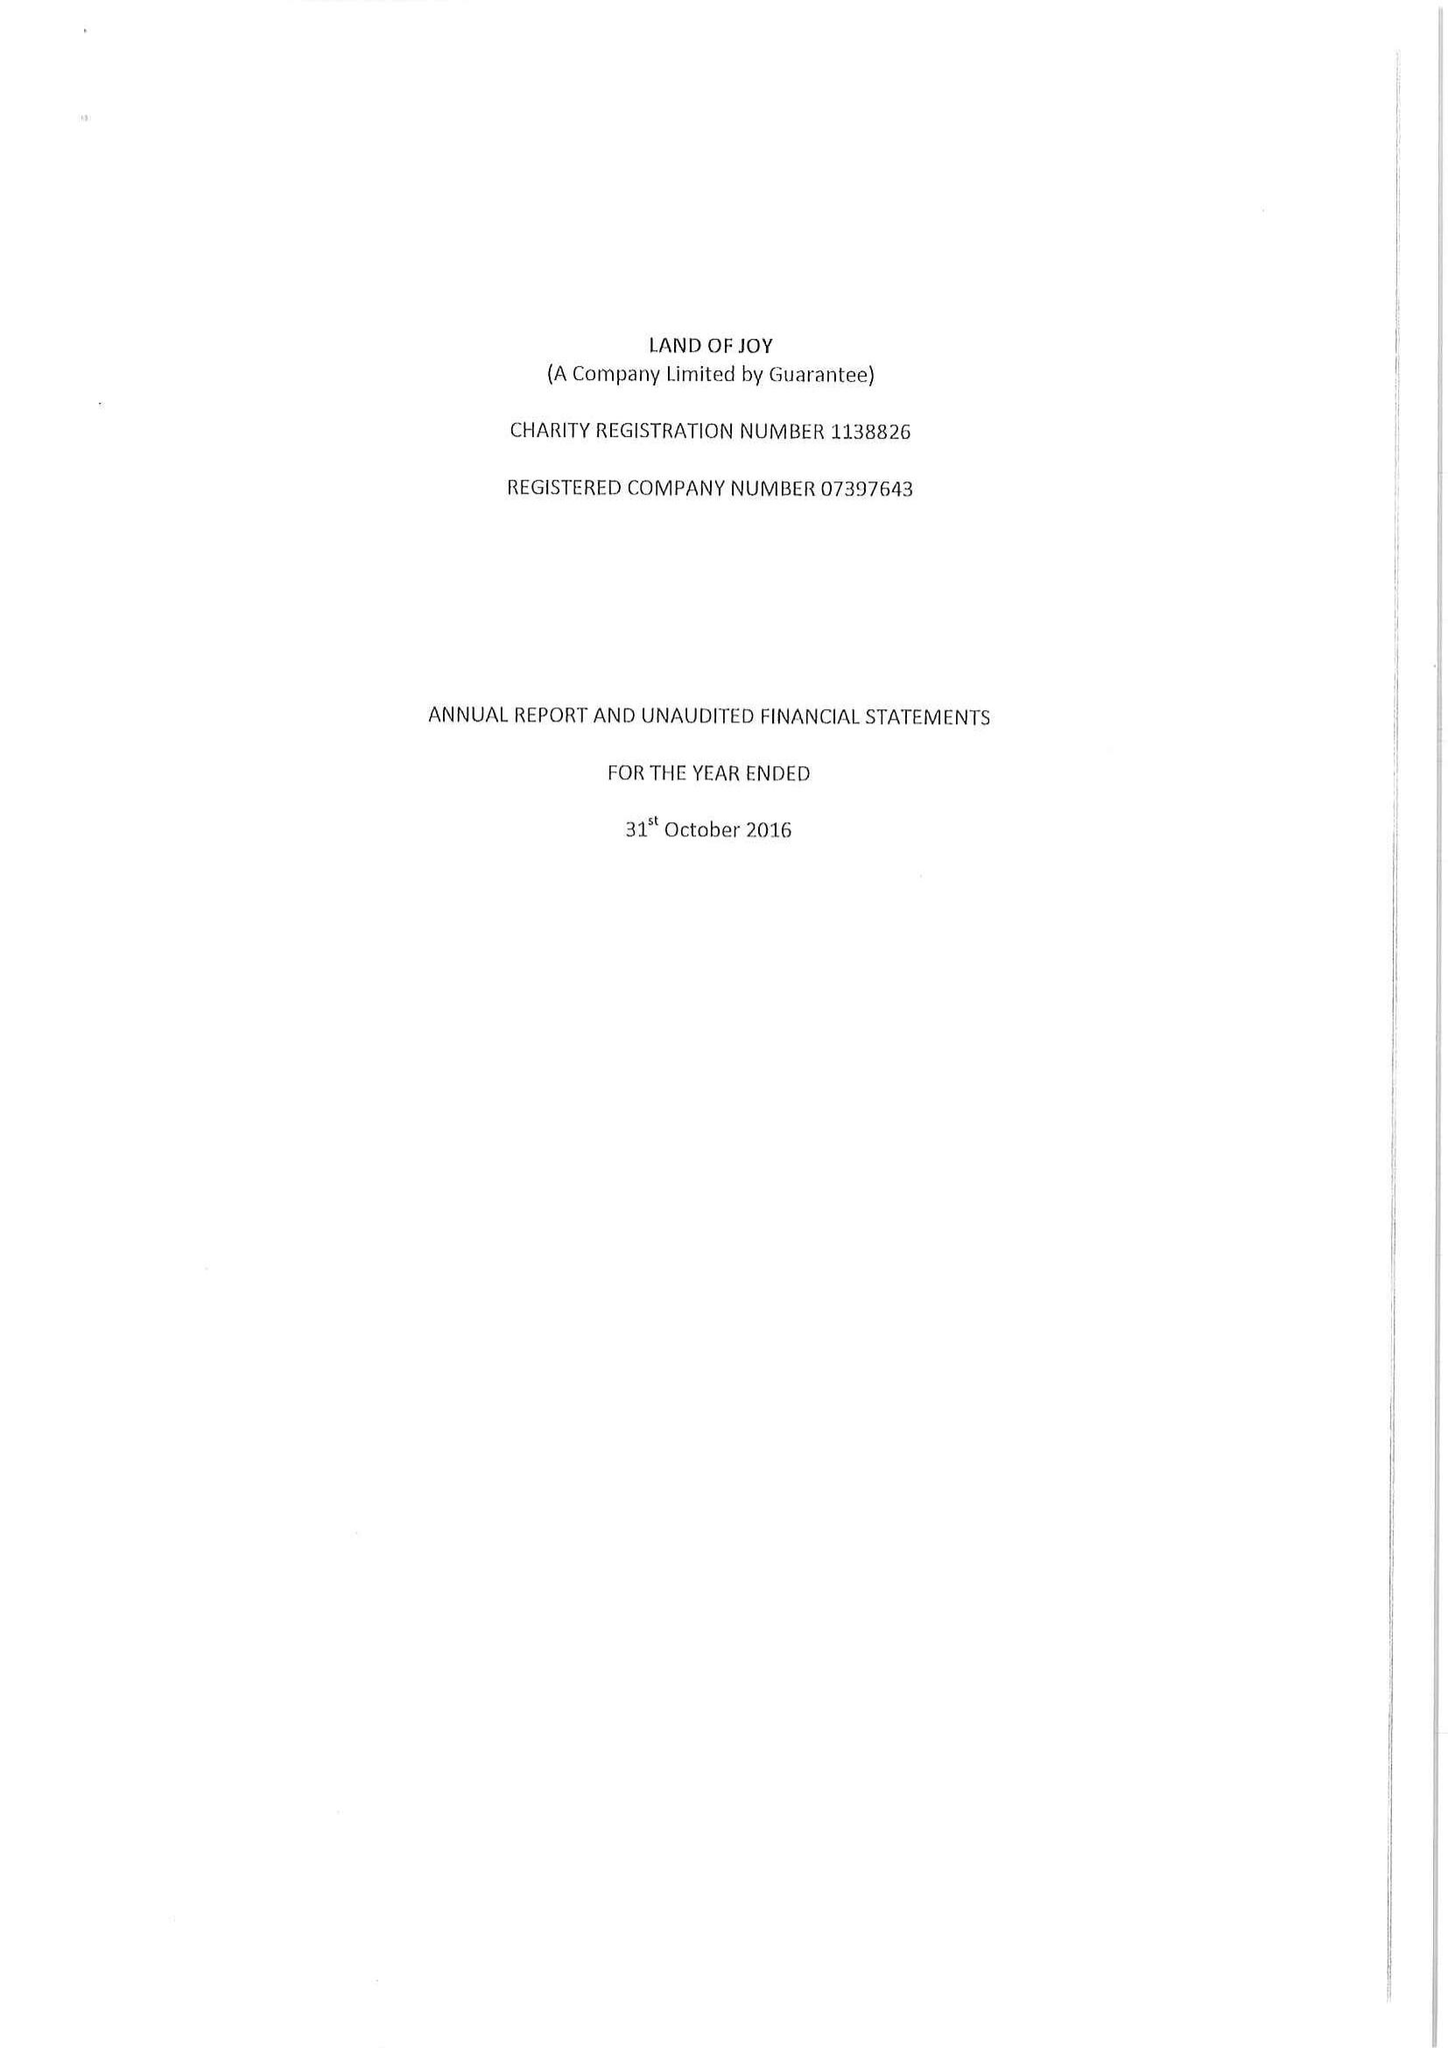What is the value for the address__street_line?
Answer the question using a single word or phrase. GREENHAUGH 